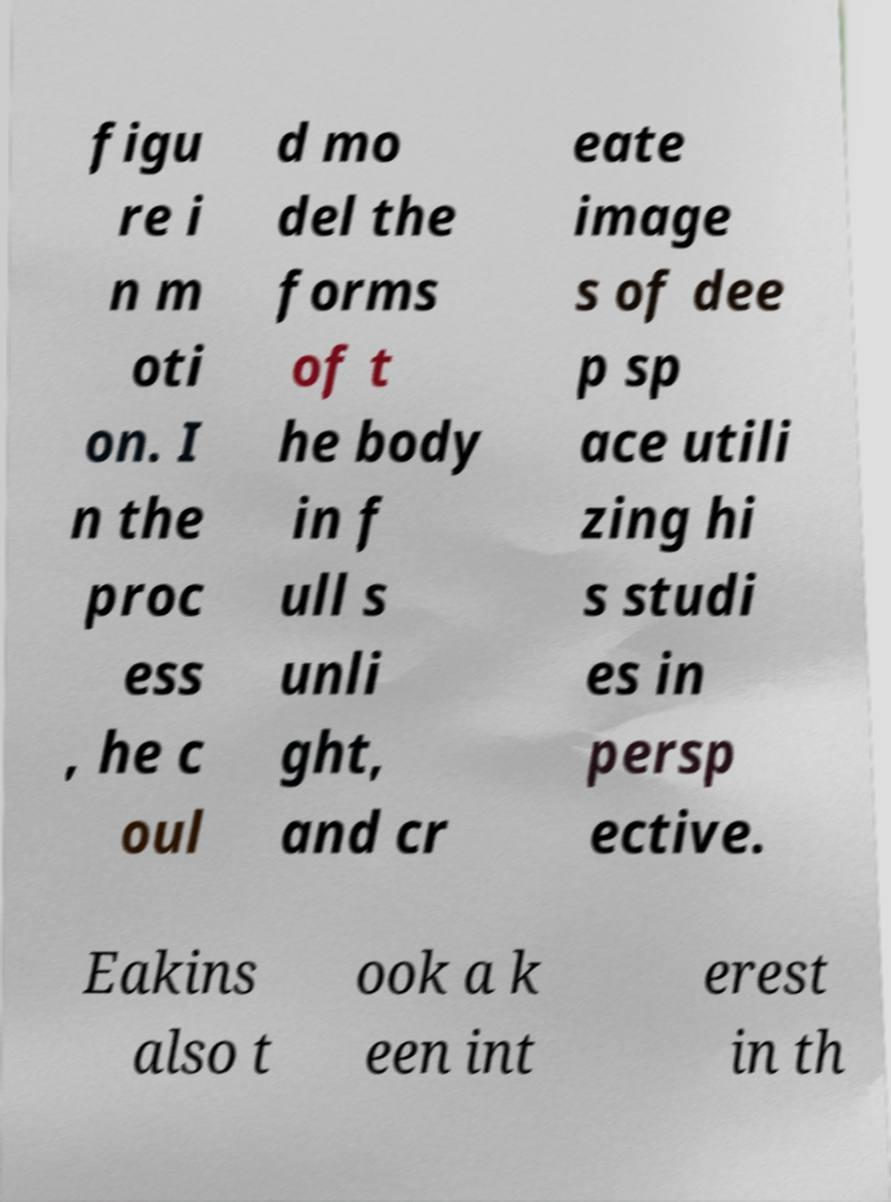Please identify and transcribe the text found in this image. figu re i n m oti on. I n the proc ess , he c oul d mo del the forms of t he body in f ull s unli ght, and cr eate image s of dee p sp ace utili zing hi s studi es in persp ective. Eakins also t ook a k een int erest in th 